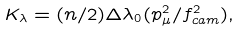<formula> <loc_0><loc_0><loc_500><loc_500>K _ { \lambda } = ( n / 2 ) \Delta \lambda _ { 0 } ( p _ { \mu } ^ { 2 } / f _ { c a m } ^ { 2 } ) ,</formula> 